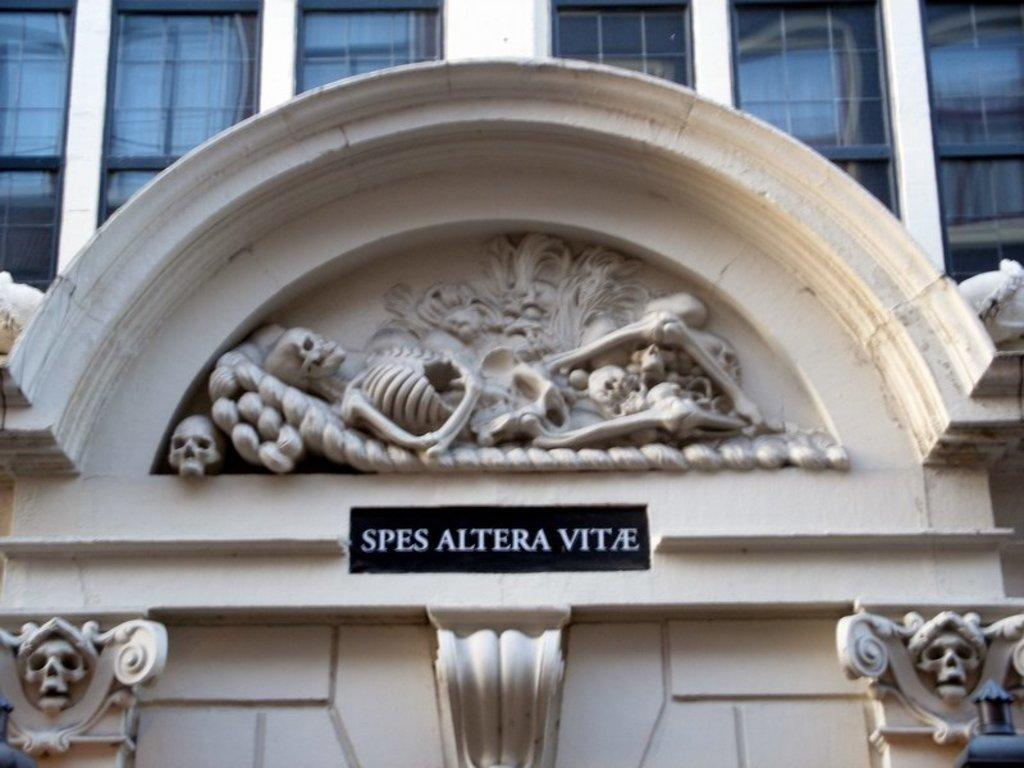What type of structure is visible in the image? There is a building in the image. What is the color of the building? The building is white in color. What is located in front of the building? There is a board and an art piece in the shape of a skeleton in front of the building. Are there any architectural features visible on the building? Yes, there are windows at the top of the building. Can you see the baby playing with the dad in the image? There is no baby or dad present in the image; it only features a building, a board, and an art piece in the shape of a skeleton. 